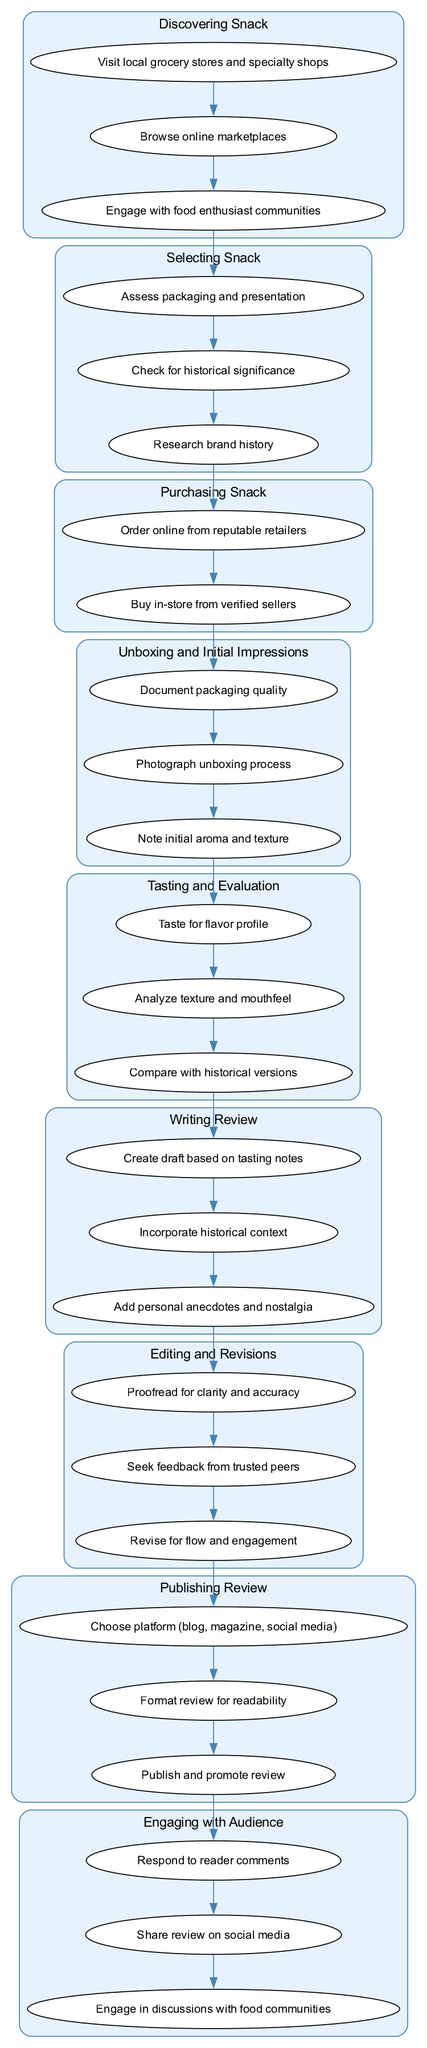What is the first step in the process? The first step is to "Discovering Snack," which is designated as the starting point of the flowchart.
Answer: Discovering Snack How many actions are there in the "Tasting and Evaluation" step? In the "Tasting and Evaluation" step, there are three actions listed, indicating the tasks associated with that stage of the process.
Answer: Three What action is performed after "Unboxing and Initial Impressions"? After "Unboxing and Initial Impressions," the next step is "Tasting and Evaluation", which follows the unboxing process in sequence.
Answer: Tasting and Evaluation Which step involves engaging with food communities? Engaging with food communities is part of the final step, which is "Engaging with Audience," as specified in the flowchart.
Answer: Engaging with Audience What is the last step in this process? The last step is "Engaging with Audience," which concludes the overall process of reviewing a classic snack.
Answer: Engaging with Audience What is the second action in the "Writing Review"? The second action in the "Writing Review" step is "Incorporate historical context," which adds depth to the review based on the evaluated snack.
Answer: Incorporate historical context Which step includes the action "Proofread for clarity and accuracy"? The action "Proofread for clarity and accuracy" is found in the "Editing and Revisions" step, where the review is refined before publishing.
Answer: Editing and Revisions How many nodes are present in the "Selecting Snack" step? In the "Selecting Snack" step, there are three nodes for actions, indicating the tasks to be completed during this stage.
Answer: Three 